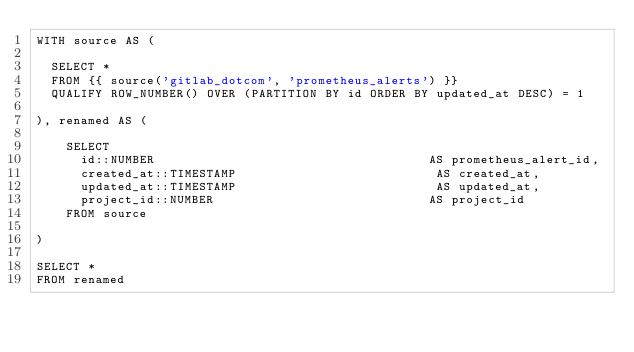<code> <loc_0><loc_0><loc_500><loc_500><_SQL_>WITH source AS (

  SELECT *
  FROM {{ source('gitlab_dotcom', 'prometheus_alerts') }}
  QUALIFY ROW_NUMBER() OVER (PARTITION BY id ORDER BY updated_at DESC) = 1

), renamed AS (

    SELECT
      id::NUMBER                                     AS prometheus_alert_id,
      created_at::TIMESTAMP                           AS created_at,
      updated_at::TIMESTAMP                           AS updated_at,
      project_id::NUMBER                             AS project_id
    FROM source

)

SELECT *
FROM renamed
</code> 